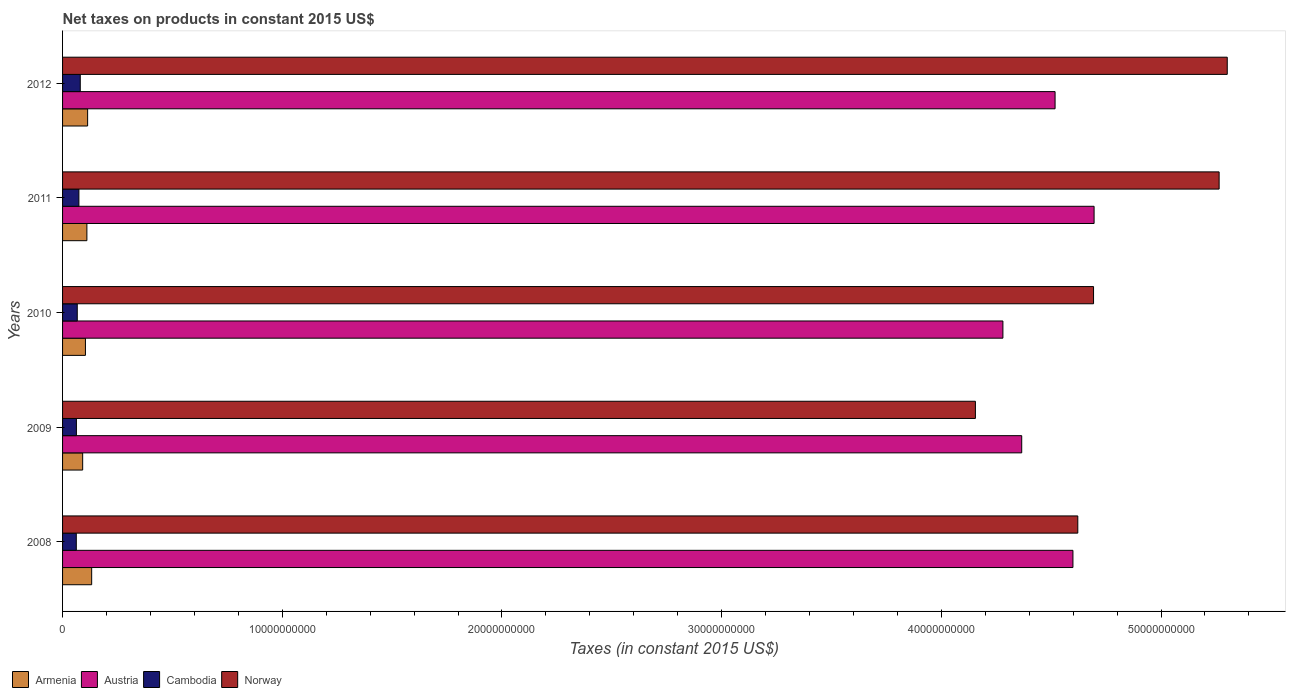Are the number of bars per tick equal to the number of legend labels?
Provide a succinct answer. Yes. Are the number of bars on each tick of the Y-axis equal?
Your answer should be very brief. Yes. How many bars are there on the 1st tick from the top?
Offer a very short reply. 4. In how many cases, is the number of bars for a given year not equal to the number of legend labels?
Offer a terse response. 0. What is the net taxes on products in Austria in 2012?
Offer a terse response. 4.52e+1. Across all years, what is the maximum net taxes on products in Austria?
Your response must be concise. 4.70e+1. Across all years, what is the minimum net taxes on products in Austria?
Keep it short and to the point. 4.28e+1. What is the total net taxes on products in Cambodia in the graph?
Ensure brevity in your answer.  3.47e+09. What is the difference between the net taxes on products in Armenia in 2010 and that in 2012?
Your answer should be compact. -9.92e+07. What is the difference between the net taxes on products in Armenia in 2011 and the net taxes on products in Norway in 2008?
Offer a very short reply. -4.51e+1. What is the average net taxes on products in Norway per year?
Keep it short and to the point. 4.81e+1. In the year 2011, what is the difference between the net taxes on products in Norway and net taxes on products in Austria?
Keep it short and to the point. 5.69e+09. In how many years, is the net taxes on products in Armenia greater than 48000000000 US$?
Keep it short and to the point. 0. What is the ratio of the net taxes on products in Cambodia in 2008 to that in 2012?
Keep it short and to the point. 0.78. Is the difference between the net taxes on products in Norway in 2010 and 2012 greater than the difference between the net taxes on products in Austria in 2010 and 2012?
Offer a terse response. No. What is the difference between the highest and the second highest net taxes on products in Armenia?
Your answer should be very brief. 1.84e+08. What is the difference between the highest and the lowest net taxes on products in Armenia?
Keep it short and to the point. 4.09e+08. In how many years, is the net taxes on products in Austria greater than the average net taxes on products in Austria taken over all years?
Your answer should be compact. 3. What does the 2nd bar from the top in 2011 represents?
Provide a succinct answer. Cambodia. What does the 3rd bar from the bottom in 2010 represents?
Your answer should be very brief. Cambodia. How many bars are there?
Keep it short and to the point. 20. What is the difference between two consecutive major ticks on the X-axis?
Provide a short and direct response. 1.00e+1. Does the graph contain any zero values?
Your answer should be compact. No. Does the graph contain grids?
Keep it short and to the point. No. Where does the legend appear in the graph?
Give a very brief answer. Bottom left. How many legend labels are there?
Provide a succinct answer. 4. What is the title of the graph?
Ensure brevity in your answer.  Net taxes on products in constant 2015 US$. What is the label or title of the X-axis?
Your response must be concise. Taxes (in constant 2015 US$). What is the label or title of the Y-axis?
Your answer should be compact. Years. What is the Taxes (in constant 2015 US$) of Armenia in 2008?
Ensure brevity in your answer.  1.32e+09. What is the Taxes (in constant 2015 US$) in Austria in 2008?
Your answer should be compact. 4.60e+1. What is the Taxes (in constant 2015 US$) in Cambodia in 2008?
Make the answer very short. 6.25e+08. What is the Taxes (in constant 2015 US$) of Norway in 2008?
Provide a succinct answer. 4.62e+1. What is the Taxes (in constant 2015 US$) of Armenia in 2009?
Offer a very short reply. 9.15e+08. What is the Taxes (in constant 2015 US$) in Austria in 2009?
Your answer should be very brief. 4.37e+1. What is the Taxes (in constant 2015 US$) in Cambodia in 2009?
Provide a succinct answer. 6.30e+08. What is the Taxes (in constant 2015 US$) in Norway in 2009?
Make the answer very short. 4.16e+1. What is the Taxes (in constant 2015 US$) in Armenia in 2010?
Give a very brief answer. 1.04e+09. What is the Taxes (in constant 2015 US$) in Austria in 2010?
Give a very brief answer. 4.28e+1. What is the Taxes (in constant 2015 US$) in Cambodia in 2010?
Make the answer very short. 6.69e+08. What is the Taxes (in constant 2015 US$) in Norway in 2010?
Give a very brief answer. 4.69e+1. What is the Taxes (in constant 2015 US$) of Armenia in 2011?
Make the answer very short. 1.11e+09. What is the Taxes (in constant 2015 US$) of Austria in 2011?
Offer a terse response. 4.70e+1. What is the Taxes (in constant 2015 US$) in Cambodia in 2011?
Your response must be concise. 7.44e+08. What is the Taxes (in constant 2015 US$) of Norway in 2011?
Provide a short and direct response. 5.26e+1. What is the Taxes (in constant 2015 US$) of Armenia in 2012?
Offer a terse response. 1.14e+09. What is the Taxes (in constant 2015 US$) of Austria in 2012?
Make the answer very short. 4.52e+1. What is the Taxes (in constant 2015 US$) in Cambodia in 2012?
Offer a terse response. 8.06e+08. What is the Taxes (in constant 2015 US$) in Norway in 2012?
Keep it short and to the point. 5.30e+1. Across all years, what is the maximum Taxes (in constant 2015 US$) of Armenia?
Make the answer very short. 1.32e+09. Across all years, what is the maximum Taxes (in constant 2015 US$) in Austria?
Provide a short and direct response. 4.70e+1. Across all years, what is the maximum Taxes (in constant 2015 US$) in Cambodia?
Give a very brief answer. 8.06e+08. Across all years, what is the maximum Taxes (in constant 2015 US$) of Norway?
Make the answer very short. 5.30e+1. Across all years, what is the minimum Taxes (in constant 2015 US$) of Armenia?
Make the answer very short. 9.15e+08. Across all years, what is the minimum Taxes (in constant 2015 US$) in Austria?
Offer a terse response. 4.28e+1. Across all years, what is the minimum Taxes (in constant 2015 US$) in Cambodia?
Make the answer very short. 6.25e+08. Across all years, what is the minimum Taxes (in constant 2015 US$) of Norway?
Offer a terse response. 4.16e+1. What is the total Taxes (in constant 2015 US$) in Armenia in the graph?
Ensure brevity in your answer.  5.53e+09. What is the total Taxes (in constant 2015 US$) in Austria in the graph?
Make the answer very short. 2.25e+11. What is the total Taxes (in constant 2015 US$) in Cambodia in the graph?
Provide a succinct answer. 3.47e+09. What is the total Taxes (in constant 2015 US$) of Norway in the graph?
Provide a short and direct response. 2.40e+11. What is the difference between the Taxes (in constant 2015 US$) of Armenia in 2008 and that in 2009?
Your answer should be very brief. 4.09e+08. What is the difference between the Taxes (in constant 2015 US$) of Austria in 2008 and that in 2009?
Offer a terse response. 2.33e+09. What is the difference between the Taxes (in constant 2015 US$) of Cambodia in 2008 and that in 2009?
Your answer should be compact. -5.33e+06. What is the difference between the Taxes (in constant 2015 US$) in Norway in 2008 and that in 2009?
Keep it short and to the point. 4.66e+09. What is the difference between the Taxes (in constant 2015 US$) in Armenia in 2008 and that in 2010?
Provide a short and direct response. 2.83e+08. What is the difference between the Taxes (in constant 2015 US$) of Austria in 2008 and that in 2010?
Offer a terse response. 3.19e+09. What is the difference between the Taxes (in constant 2015 US$) of Cambodia in 2008 and that in 2010?
Keep it short and to the point. -4.40e+07. What is the difference between the Taxes (in constant 2015 US$) in Norway in 2008 and that in 2010?
Your answer should be compact. -7.17e+08. What is the difference between the Taxes (in constant 2015 US$) in Armenia in 2008 and that in 2011?
Make the answer very short. 2.18e+08. What is the difference between the Taxes (in constant 2015 US$) of Austria in 2008 and that in 2011?
Ensure brevity in your answer.  -9.63e+08. What is the difference between the Taxes (in constant 2015 US$) in Cambodia in 2008 and that in 2011?
Keep it short and to the point. -1.19e+08. What is the difference between the Taxes (in constant 2015 US$) of Norway in 2008 and that in 2011?
Offer a terse response. -6.43e+09. What is the difference between the Taxes (in constant 2015 US$) of Armenia in 2008 and that in 2012?
Ensure brevity in your answer.  1.84e+08. What is the difference between the Taxes (in constant 2015 US$) of Austria in 2008 and that in 2012?
Your answer should be compact. 8.13e+08. What is the difference between the Taxes (in constant 2015 US$) of Cambodia in 2008 and that in 2012?
Provide a succinct answer. -1.81e+08. What is the difference between the Taxes (in constant 2015 US$) of Norway in 2008 and that in 2012?
Offer a very short reply. -6.80e+09. What is the difference between the Taxes (in constant 2015 US$) in Armenia in 2009 and that in 2010?
Provide a succinct answer. -1.26e+08. What is the difference between the Taxes (in constant 2015 US$) in Austria in 2009 and that in 2010?
Offer a terse response. 8.56e+08. What is the difference between the Taxes (in constant 2015 US$) in Cambodia in 2009 and that in 2010?
Give a very brief answer. -3.87e+07. What is the difference between the Taxes (in constant 2015 US$) of Norway in 2009 and that in 2010?
Provide a succinct answer. -5.38e+09. What is the difference between the Taxes (in constant 2015 US$) in Armenia in 2009 and that in 2011?
Provide a short and direct response. -1.91e+08. What is the difference between the Taxes (in constant 2015 US$) in Austria in 2009 and that in 2011?
Your response must be concise. -3.29e+09. What is the difference between the Taxes (in constant 2015 US$) in Cambodia in 2009 and that in 2011?
Your answer should be compact. -1.14e+08. What is the difference between the Taxes (in constant 2015 US$) of Norway in 2009 and that in 2011?
Ensure brevity in your answer.  -1.11e+1. What is the difference between the Taxes (in constant 2015 US$) in Armenia in 2009 and that in 2012?
Your answer should be compact. -2.25e+08. What is the difference between the Taxes (in constant 2015 US$) of Austria in 2009 and that in 2012?
Keep it short and to the point. -1.52e+09. What is the difference between the Taxes (in constant 2015 US$) of Cambodia in 2009 and that in 2012?
Provide a short and direct response. -1.76e+08. What is the difference between the Taxes (in constant 2015 US$) in Norway in 2009 and that in 2012?
Keep it short and to the point. -1.15e+1. What is the difference between the Taxes (in constant 2015 US$) of Armenia in 2010 and that in 2011?
Give a very brief answer. -6.55e+07. What is the difference between the Taxes (in constant 2015 US$) of Austria in 2010 and that in 2011?
Provide a succinct answer. -4.15e+09. What is the difference between the Taxes (in constant 2015 US$) of Cambodia in 2010 and that in 2011?
Your response must be concise. -7.49e+07. What is the difference between the Taxes (in constant 2015 US$) of Norway in 2010 and that in 2011?
Your answer should be compact. -5.72e+09. What is the difference between the Taxes (in constant 2015 US$) in Armenia in 2010 and that in 2012?
Your response must be concise. -9.92e+07. What is the difference between the Taxes (in constant 2015 US$) of Austria in 2010 and that in 2012?
Give a very brief answer. -2.37e+09. What is the difference between the Taxes (in constant 2015 US$) of Cambodia in 2010 and that in 2012?
Provide a short and direct response. -1.37e+08. What is the difference between the Taxes (in constant 2015 US$) of Norway in 2010 and that in 2012?
Your answer should be very brief. -6.09e+09. What is the difference between the Taxes (in constant 2015 US$) of Armenia in 2011 and that in 2012?
Ensure brevity in your answer.  -3.36e+07. What is the difference between the Taxes (in constant 2015 US$) in Austria in 2011 and that in 2012?
Give a very brief answer. 1.78e+09. What is the difference between the Taxes (in constant 2015 US$) of Cambodia in 2011 and that in 2012?
Ensure brevity in your answer.  -6.22e+07. What is the difference between the Taxes (in constant 2015 US$) of Norway in 2011 and that in 2012?
Make the answer very short. -3.70e+08. What is the difference between the Taxes (in constant 2015 US$) of Armenia in 2008 and the Taxes (in constant 2015 US$) of Austria in 2009?
Provide a succinct answer. -4.23e+1. What is the difference between the Taxes (in constant 2015 US$) of Armenia in 2008 and the Taxes (in constant 2015 US$) of Cambodia in 2009?
Keep it short and to the point. 6.94e+08. What is the difference between the Taxes (in constant 2015 US$) in Armenia in 2008 and the Taxes (in constant 2015 US$) in Norway in 2009?
Make the answer very short. -4.02e+1. What is the difference between the Taxes (in constant 2015 US$) in Austria in 2008 and the Taxes (in constant 2015 US$) in Cambodia in 2009?
Give a very brief answer. 4.54e+1. What is the difference between the Taxes (in constant 2015 US$) in Austria in 2008 and the Taxes (in constant 2015 US$) in Norway in 2009?
Your answer should be very brief. 4.44e+09. What is the difference between the Taxes (in constant 2015 US$) of Cambodia in 2008 and the Taxes (in constant 2015 US$) of Norway in 2009?
Keep it short and to the point. -4.09e+1. What is the difference between the Taxes (in constant 2015 US$) of Armenia in 2008 and the Taxes (in constant 2015 US$) of Austria in 2010?
Provide a short and direct response. -4.15e+1. What is the difference between the Taxes (in constant 2015 US$) in Armenia in 2008 and the Taxes (in constant 2015 US$) in Cambodia in 2010?
Ensure brevity in your answer.  6.56e+08. What is the difference between the Taxes (in constant 2015 US$) in Armenia in 2008 and the Taxes (in constant 2015 US$) in Norway in 2010?
Your response must be concise. -4.56e+1. What is the difference between the Taxes (in constant 2015 US$) of Austria in 2008 and the Taxes (in constant 2015 US$) of Cambodia in 2010?
Provide a short and direct response. 4.53e+1. What is the difference between the Taxes (in constant 2015 US$) in Austria in 2008 and the Taxes (in constant 2015 US$) in Norway in 2010?
Offer a terse response. -9.38e+08. What is the difference between the Taxes (in constant 2015 US$) of Cambodia in 2008 and the Taxes (in constant 2015 US$) of Norway in 2010?
Provide a succinct answer. -4.63e+1. What is the difference between the Taxes (in constant 2015 US$) in Armenia in 2008 and the Taxes (in constant 2015 US$) in Austria in 2011?
Your response must be concise. -4.56e+1. What is the difference between the Taxes (in constant 2015 US$) of Armenia in 2008 and the Taxes (in constant 2015 US$) of Cambodia in 2011?
Offer a terse response. 5.81e+08. What is the difference between the Taxes (in constant 2015 US$) in Armenia in 2008 and the Taxes (in constant 2015 US$) in Norway in 2011?
Ensure brevity in your answer.  -5.13e+1. What is the difference between the Taxes (in constant 2015 US$) in Austria in 2008 and the Taxes (in constant 2015 US$) in Cambodia in 2011?
Provide a short and direct response. 4.52e+1. What is the difference between the Taxes (in constant 2015 US$) of Austria in 2008 and the Taxes (in constant 2015 US$) of Norway in 2011?
Offer a terse response. -6.65e+09. What is the difference between the Taxes (in constant 2015 US$) of Cambodia in 2008 and the Taxes (in constant 2015 US$) of Norway in 2011?
Your response must be concise. -5.20e+1. What is the difference between the Taxes (in constant 2015 US$) in Armenia in 2008 and the Taxes (in constant 2015 US$) in Austria in 2012?
Make the answer very short. -4.39e+1. What is the difference between the Taxes (in constant 2015 US$) of Armenia in 2008 and the Taxes (in constant 2015 US$) of Cambodia in 2012?
Give a very brief answer. 5.19e+08. What is the difference between the Taxes (in constant 2015 US$) of Armenia in 2008 and the Taxes (in constant 2015 US$) of Norway in 2012?
Ensure brevity in your answer.  -5.17e+1. What is the difference between the Taxes (in constant 2015 US$) of Austria in 2008 and the Taxes (in constant 2015 US$) of Cambodia in 2012?
Make the answer very short. 4.52e+1. What is the difference between the Taxes (in constant 2015 US$) in Austria in 2008 and the Taxes (in constant 2015 US$) in Norway in 2012?
Provide a succinct answer. -7.02e+09. What is the difference between the Taxes (in constant 2015 US$) in Cambodia in 2008 and the Taxes (in constant 2015 US$) in Norway in 2012?
Your answer should be compact. -5.24e+1. What is the difference between the Taxes (in constant 2015 US$) of Armenia in 2009 and the Taxes (in constant 2015 US$) of Austria in 2010?
Your answer should be compact. -4.19e+1. What is the difference between the Taxes (in constant 2015 US$) in Armenia in 2009 and the Taxes (in constant 2015 US$) in Cambodia in 2010?
Make the answer very short. 2.47e+08. What is the difference between the Taxes (in constant 2015 US$) in Armenia in 2009 and the Taxes (in constant 2015 US$) in Norway in 2010?
Your answer should be compact. -4.60e+1. What is the difference between the Taxes (in constant 2015 US$) of Austria in 2009 and the Taxes (in constant 2015 US$) of Cambodia in 2010?
Provide a short and direct response. 4.30e+1. What is the difference between the Taxes (in constant 2015 US$) of Austria in 2009 and the Taxes (in constant 2015 US$) of Norway in 2010?
Your answer should be very brief. -3.27e+09. What is the difference between the Taxes (in constant 2015 US$) of Cambodia in 2009 and the Taxes (in constant 2015 US$) of Norway in 2010?
Offer a very short reply. -4.63e+1. What is the difference between the Taxes (in constant 2015 US$) in Armenia in 2009 and the Taxes (in constant 2015 US$) in Austria in 2011?
Offer a terse response. -4.60e+1. What is the difference between the Taxes (in constant 2015 US$) of Armenia in 2009 and the Taxes (in constant 2015 US$) of Cambodia in 2011?
Provide a short and direct response. 1.72e+08. What is the difference between the Taxes (in constant 2015 US$) in Armenia in 2009 and the Taxes (in constant 2015 US$) in Norway in 2011?
Make the answer very short. -5.17e+1. What is the difference between the Taxes (in constant 2015 US$) of Austria in 2009 and the Taxes (in constant 2015 US$) of Cambodia in 2011?
Give a very brief answer. 4.29e+1. What is the difference between the Taxes (in constant 2015 US$) in Austria in 2009 and the Taxes (in constant 2015 US$) in Norway in 2011?
Give a very brief answer. -8.99e+09. What is the difference between the Taxes (in constant 2015 US$) in Cambodia in 2009 and the Taxes (in constant 2015 US$) in Norway in 2011?
Ensure brevity in your answer.  -5.20e+1. What is the difference between the Taxes (in constant 2015 US$) in Armenia in 2009 and the Taxes (in constant 2015 US$) in Austria in 2012?
Your answer should be compact. -4.43e+1. What is the difference between the Taxes (in constant 2015 US$) of Armenia in 2009 and the Taxes (in constant 2015 US$) of Cambodia in 2012?
Offer a very short reply. 1.10e+08. What is the difference between the Taxes (in constant 2015 US$) of Armenia in 2009 and the Taxes (in constant 2015 US$) of Norway in 2012?
Ensure brevity in your answer.  -5.21e+1. What is the difference between the Taxes (in constant 2015 US$) of Austria in 2009 and the Taxes (in constant 2015 US$) of Cambodia in 2012?
Make the answer very short. 4.29e+1. What is the difference between the Taxes (in constant 2015 US$) of Austria in 2009 and the Taxes (in constant 2015 US$) of Norway in 2012?
Provide a short and direct response. -9.36e+09. What is the difference between the Taxes (in constant 2015 US$) in Cambodia in 2009 and the Taxes (in constant 2015 US$) in Norway in 2012?
Offer a terse response. -5.24e+1. What is the difference between the Taxes (in constant 2015 US$) of Armenia in 2010 and the Taxes (in constant 2015 US$) of Austria in 2011?
Ensure brevity in your answer.  -4.59e+1. What is the difference between the Taxes (in constant 2015 US$) of Armenia in 2010 and the Taxes (in constant 2015 US$) of Cambodia in 2011?
Offer a terse response. 2.98e+08. What is the difference between the Taxes (in constant 2015 US$) of Armenia in 2010 and the Taxes (in constant 2015 US$) of Norway in 2011?
Provide a succinct answer. -5.16e+1. What is the difference between the Taxes (in constant 2015 US$) in Austria in 2010 and the Taxes (in constant 2015 US$) in Cambodia in 2011?
Offer a very short reply. 4.21e+1. What is the difference between the Taxes (in constant 2015 US$) in Austria in 2010 and the Taxes (in constant 2015 US$) in Norway in 2011?
Your response must be concise. -9.84e+09. What is the difference between the Taxes (in constant 2015 US$) in Cambodia in 2010 and the Taxes (in constant 2015 US$) in Norway in 2011?
Keep it short and to the point. -5.20e+1. What is the difference between the Taxes (in constant 2015 US$) in Armenia in 2010 and the Taxes (in constant 2015 US$) in Austria in 2012?
Offer a very short reply. -4.41e+1. What is the difference between the Taxes (in constant 2015 US$) of Armenia in 2010 and the Taxes (in constant 2015 US$) of Cambodia in 2012?
Offer a terse response. 2.36e+08. What is the difference between the Taxes (in constant 2015 US$) of Armenia in 2010 and the Taxes (in constant 2015 US$) of Norway in 2012?
Provide a succinct answer. -5.20e+1. What is the difference between the Taxes (in constant 2015 US$) in Austria in 2010 and the Taxes (in constant 2015 US$) in Cambodia in 2012?
Ensure brevity in your answer.  4.20e+1. What is the difference between the Taxes (in constant 2015 US$) in Austria in 2010 and the Taxes (in constant 2015 US$) in Norway in 2012?
Make the answer very short. -1.02e+1. What is the difference between the Taxes (in constant 2015 US$) of Cambodia in 2010 and the Taxes (in constant 2015 US$) of Norway in 2012?
Offer a very short reply. -5.23e+1. What is the difference between the Taxes (in constant 2015 US$) in Armenia in 2011 and the Taxes (in constant 2015 US$) in Austria in 2012?
Make the answer very short. -4.41e+1. What is the difference between the Taxes (in constant 2015 US$) in Armenia in 2011 and the Taxes (in constant 2015 US$) in Cambodia in 2012?
Make the answer very short. 3.01e+08. What is the difference between the Taxes (in constant 2015 US$) of Armenia in 2011 and the Taxes (in constant 2015 US$) of Norway in 2012?
Provide a short and direct response. -5.19e+1. What is the difference between the Taxes (in constant 2015 US$) of Austria in 2011 and the Taxes (in constant 2015 US$) of Cambodia in 2012?
Make the answer very short. 4.61e+1. What is the difference between the Taxes (in constant 2015 US$) in Austria in 2011 and the Taxes (in constant 2015 US$) in Norway in 2012?
Provide a short and direct response. -6.06e+09. What is the difference between the Taxes (in constant 2015 US$) in Cambodia in 2011 and the Taxes (in constant 2015 US$) in Norway in 2012?
Make the answer very short. -5.23e+1. What is the average Taxes (in constant 2015 US$) in Armenia per year?
Give a very brief answer. 1.11e+09. What is the average Taxes (in constant 2015 US$) of Austria per year?
Make the answer very short. 4.49e+1. What is the average Taxes (in constant 2015 US$) in Cambodia per year?
Give a very brief answer. 6.95e+08. What is the average Taxes (in constant 2015 US$) in Norway per year?
Offer a terse response. 4.81e+1. In the year 2008, what is the difference between the Taxes (in constant 2015 US$) of Armenia and Taxes (in constant 2015 US$) of Austria?
Offer a very short reply. -4.47e+1. In the year 2008, what is the difference between the Taxes (in constant 2015 US$) of Armenia and Taxes (in constant 2015 US$) of Cambodia?
Your answer should be very brief. 7.00e+08. In the year 2008, what is the difference between the Taxes (in constant 2015 US$) of Armenia and Taxes (in constant 2015 US$) of Norway?
Your response must be concise. -4.49e+1. In the year 2008, what is the difference between the Taxes (in constant 2015 US$) in Austria and Taxes (in constant 2015 US$) in Cambodia?
Provide a succinct answer. 4.54e+1. In the year 2008, what is the difference between the Taxes (in constant 2015 US$) in Austria and Taxes (in constant 2015 US$) in Norway?
Your answer should be compact. -2.21e+08. In the year 2008, what is the difference between the Taxes (in constant 2015 US$) of Cambodia and Taxes (in constant 2015 US$) of Norway?
Make the answer very short. -4.56e+1. In the year 2009, what is the difference between the Taxes (in constant 2015 US$) of Armenia and Taxes (in constant 2015 US$) of Austria?
Provide a succinct answer. -4.27e+1. In the year 2009, what is the difference between the Taxes (in constant 2015 US$) of Armenia and Taxes (in constant 2015 US$) of Cambodia?
Give a very brief answer. 2.85e+08. In the year 2009, what is the difference between the Taxes (in constant 2015 US$) of Armenia and Taxes (in constant 2015 US$) of Norway?
Your answer should be compact. -4.06e+1. In the year 2009, what is the difference between the Taxes (in constant 2015 US$) in Austria and Taxes (in constant 2015 US$) in Cambodia?
Your response must be concise. 4.30e+1. In the year 2009, what is the difference between the Taxes (in constant 2015 US$) in Austria and Taxes (in constant 2015 US$) in Norway?
Offer a very short reply. 2.11e+09. In the year 2009, what is the difference between the Taxes (in constant 2015 US$) in Cambodia and Taxes (in constant 2015 US$) in Norway?
Give a very brief answer. -4.09e+1. In the year 2010, what is the difference between the Taxes (in constant 2015 US$) in Armenia and Taxes (in constant 2015 US$) in Austria?
Keep it short and to the point. -4.18e+1. In the year 2010, what is the difference between the Taxes (in constant 2015 US$) of Armenia and Taxes (in constant 2015 US$) of Cambodia?
Keep it short and to the point. 3.73e+08. In the year 2010, what is the difference between the Taxes (in constant 2015 US$) of Armenia and Taxes (in constant 2015 US$) of Norway?
Ensure brevity in your answer.  -4.59e+1. In the year 2010, what is the difference between the Taxes (in constant 2015 US$) of Austria and Taxes (in constant 2015 US$) of Cambodia?
Ensure brevity in your answer.  4.21e+1. In the year 2010, what is the difference between the Taxes (in constant 2015 US$) in Austria and Taxes (in constant 2015 US$) in Norway?
Make the answer very short. -4.13e+09. In the year 2010, what is the difference between the Taxes (in constant 2015 US$) in Cambodia and Taxes (in constant 2015 US$) in Norway?
Offer a terse response. -4.63e+1. In the year 2011, what is the difference between the Taxes (in constant 2015 US$) in Armenia and Taxes (in constant 2015 US$) in Austria?
Provide a succinct answer. -4.58e+1. In the year 2011, what is the difference between the Taxes (in constant 2015 US$) in Armenia and Taxes (in constant 2015 US$) in Cambodia?
Ensure brevity in your answer.  3.63e+08. In the year 2011, what is the difference between the Taxes (in constant 2015 US$) in Armenia and Taxes (in constant 2015 US$) in Norway?
Offer a very short reply. -5.15e+1. In the year 2011, what is the difference between the Taxes (in constant 2015 US$) of Austria and Taxes (in constant 2015 US$) of Cambodia?
Provide a succinct answer. 4.62e+1. In the year 2011, what is the difference between the Taxes (in constant 2015 US$) in Austria and Taxes (in constant 2015 US$) in Norway?
Keep it short and to the point. -5.69e+09. In the year 2011, what is the difference between the Taxes (in constant 2015 US$) of Cambodia and Taxes (in constant 2015 US$) of Norway?
Your answer should be compact. -5.19e+1. In the year 2012, what is the difference between the Taxes (in constant 2015 US$) in Armenia and Taxes (in constant 2015 US$) in Austria?
Ensure brevity in your answer.  -4.40e+1. In the year 2012, what is the difference between the Taxes (in constant 2015 US$) in Armenia and Taxes (in constant 2015 US$) in Cambodia?
Offer a very short reply. 3.35e+08. In the year 2012, what is the difference between the Taxes (in constant 2015 US$) of Armenia and Taxes (in constant 2015 US$) of Norway?
Provide a succinct answer. -5.19e+1. In the year 2012, what is the difference between the Taxes (in constant 2015 US$) in Austria and Taxes (in constant 2015 US$) in Cambodia?
Give a very brief answer. 4.44e+1. In the year 2012, what is the difference between the Taxes (in constant 2015 US$) of Austria and Taxes (in constant 2015 US$) of Norway?
Your answer should be compact. -7.84e+09. In the year 2012, what is the difference between the Taxes (in constant 2015 US$) of Cambodia and Taxes (in constant 2015 US$) of Norway?
Your response must be concise. -5.22e+1. What is the ratio of the Taxes (in constant 2015 US$) in Armenia in 2008 to that in 2009?
Ensure brevity in your answer.  1.45. What is the ratio of the Taxes (in constant 2015 US$) in Austria in 2008 to that in 2009?
Make the answer very short. 1.05. What is the ratio of the Taxes (in constant 2015 US$) of Cambodia in 2008 to that in 2009?
Your response must be concise. 0.99. What is the ratio of the Taxes (in constant 2015 US$) of Norway in 2008 to that in 2009?
Ensure brevity in your answer.  1.11. What is the ratio of the Taxes (in constant 2015 US$) of Armenia in 2008 to that in 2010?
Your answer should be very brief. 1.27. What is the ratio of the Taxes (in constant 2015 US$) in Austria in 2008 to that in 2010?
Offer a very short reply. 1.07. What is the ratio of the Taxes (in constant 2015 US$) in Cambodia in 2008 to that in 2010?
Your response must be concise. 0.93. What is the ratio of the Taxes (in constant 2015 US$) of Norway in 2008 to that in 2010?
Your answer should be very brief. 0.98. What is the ratio of the Taxes (in constant 2015 US$) in Armenia in 2008 to that in 2011?
Ensure brevity in your answer.  1.2. What is the ratio of the Taxes (in constant 2015 US$) of Austria in 2008 to that in 2011?
Give a very brief answer. 0.98. What is the ratio of the Taxes (in constant 2015 US$) of Cambodia in 2008 to that in 2011?
Your response must be concise. 0.84. What is the ratio of the Taxes (in constant 2015 US$) of Norway in 2008 to that in 2011?
Your response must be concise. 0.88. What is the ratio of the Taxes (in constant 2015 US$) in Armenia in 2008 to that in 2012?
Offer a terse response. 1.16. What is the ratio of the Taxes (in constant 2015 US$) in Austria in 2008 to that in 2012?
Provide a short and direct response. 1.02. What is the ratio of the Taxes (in constant 2015 US$) in Cambodia in 2008 to that in 2012?
Keep it short and to the point. 0.78. What is the ratio of the Taxes (in constant 2015 US$) in Norway in 2008 to that in 2012?
Give a very brief answer. 0.87. What is the ratio of the Taxes (in constant 2015 US$) in Armenia in 2009 to that in 2010?
Your answer should be compact. 0.88. What is the ratio of the Taxes (in constant 2015 US$) of Cambodia in 2009 to that in 2010?
Your answer should be compact. 0.94. What is the ratio of the Taxes (in constant 2015 US$) of Norway in 2009 to that in 2010?
Provide a succinct answer. 0.89. What is the ratio of the Taxes (in constant 2015 US$) in Armenia in 2009 to that in 2011?
Offer a terse response. 0.83. What is the ratio of the Taxes (in constant 2015 US$) of Austria in 2009 to that in 2011?
Your answer should be very brief. 0.93. What is the ratio of the Taxes (in constant 2015 US$) in Cambodia in 2009 to that in 2011?
Offer a terse response. 0.85. What is the ratio of the Taxes (in constant 2015 US$) of Norway in 2009 to that in 2011?
Keep it short and to the point. 0.79. What is the ratio of the Taxes (in constant 2015 US$) of Armenia in 2009 to that in 2012?
Your answer should be compact. 0.8. What is the ratio of the Taxes (in constant 2015 US$) of Austria in 2009 to that in 2012?
Your answer should be very brief. 0.97. What is the ratio of the Taxes (in constant 2015 US$) of Cambodia in 2009 to that in 2012?
Offer a terse response. 0.78. What is the ratio of the Taxes (in constant 2015 US$) in Norway in 2009 to that in 2012?
Provide a succinct answer. 0.78. What is the ratio of the Taxes (in constant 2015 US$) of Armenia in 2010 to that in 2011?
Provide a short and direct response. 0.94. What is the ratio of the Taxes (in constant 2015 US$) of Austria in 2010 to that in 2011?
Your response must be concise. 0.91. What is the ratio of the Taxes (in constant 2015 US$) in Cambodia in 2010 to that in 2011?
Offer a terse response. 0.9. What is the ratio of the Taxes (in constant 2015 US$) of Norway in 2010 to that in 2011?
Offer a terse response. 0.89. What is the ratio of the Taxes (in constant 2015 US$) of Armenia in 2010 to that in 2012?
Keep it short and to the point. 0.91. What is the ratio of the Taxes (in constant 2015 US$) in Cambodia in 2010 to that in 2012?
Your response must be concise. 0.83. What is the ratio of the Taxes (in constant 2015 US$) in Norway in 2010 to that in 2012?
Your response must be concise. 0.89. What is the ratio of the Taxes (in constant 2015 US$) in Armenia in 2011 to that in 2012?
Make the answer very short. 0.97. What is the ratio of the Taxes (in constant 2015 US$) of Austria in 2011 to that in 2012?
Make the answer very short. 1.04. What is the ratio of the Taxes (in constant 2015 US$) of Cambodia in 2011 to that in 2012?
Make the answer very short. 0.92. What is the ratio of the Taxes (in constant 2015 US$) in Norway in 2011 to that in 2012?
Provide a short and direct response. 0.99. What is the difference between the highest and the second highest Taxes (in constant 2015 US$) of Armenia?
Ensure brevity in your answer.  1.84e+08. What is the difference between the highest and the second highest Taxes (in constant 2015 US$) in Austria?
Provide a succinct answer. 9.63e+08. What is the difference between the highest and the second highest Taxes (in constant 2015 US$) in Cambodia?
Give a very brief answer. 6.22e+07. What is the difference between the highest and the second highest Taxes (in constant 2015 US$) in Norway?
Keep it short and to the point. 3.70e+08. What is the difference between the highest and the lowest Taxes (in constant 2015 US$) of Armenia?
Your answer should be compact. 4.09e+08. What is the difference between the highest and the lowest Taxes (in constant 2015 US$) of Austria?
Offer a terse response. 4.15e+09. What is the difference between the highest and the lowest Taxes (in constant 2015 US$) in Cambodia?
Offer a very short reply. 1.81e+08. What is the difference between the highest and the lowest Taxes (in constant 2015 US$) of Norway?
Offer a very short reply. 1.15e+1. 